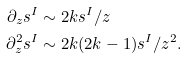Convert formula to latex. <formula><loc_0><loc_0><loc_500><loc_500>\partial _ { z } s ^ { I } & \sim 2 k s ^ { I } / z \\ \partial _ { z } ^ { 2 } s ^ { I } & \sim 2 k ( 2 k - 1 ) s ^ { I } / z ^ { 2 } .</formula> 